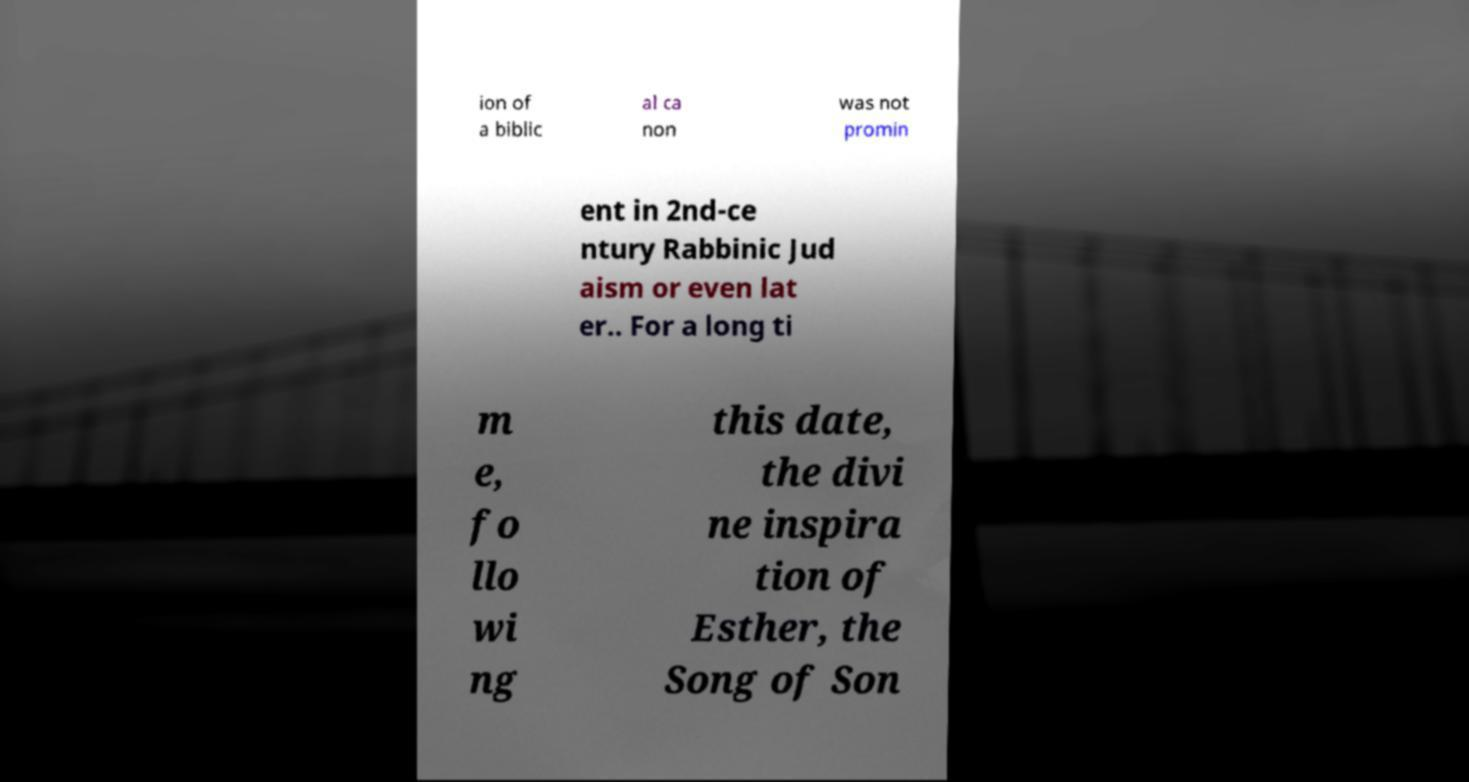Can you read and provide the text displayed in the image?This photo seems to have some interesting text. Can you extract and type it out for me? ion of a biblic al ca non was not promin ent in 2nd-ce ntury Rabbinic Jud aism or even lat er.. For a long ti m e, fo llo wi ng this date, the divi ne inspira tion of Esther, the Song of Son 